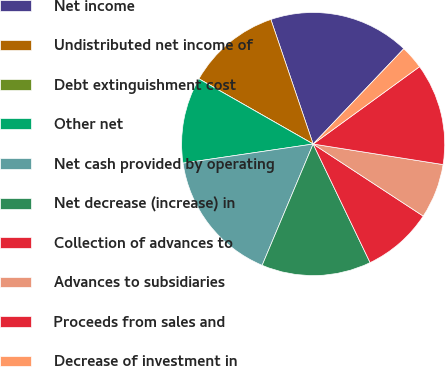<chart> <loc_0><loc_0><loc_500><loc_500><pie_chart><fcel>Net income<fcel>Undistributed net income of<fcel>Debt extinguishment cost<fcel>Other net<fcel>Net cash provided by operating<fcel>Net decrease (increase) in<fcel>Collection of advances to<fcel>Advances to subsidiaries<fcel>Proceeds from sales and<fcel>Decrease of investment in<nl><fcel>17.31%<fcel>11.54%<fcel>0.0%<fcel>10.58%<fcel>16.34%<fcel>13.46%<fcel>8.65%<fcel>6.73%<fcel>12.5%<fcel>2.89%<nl></chart> 